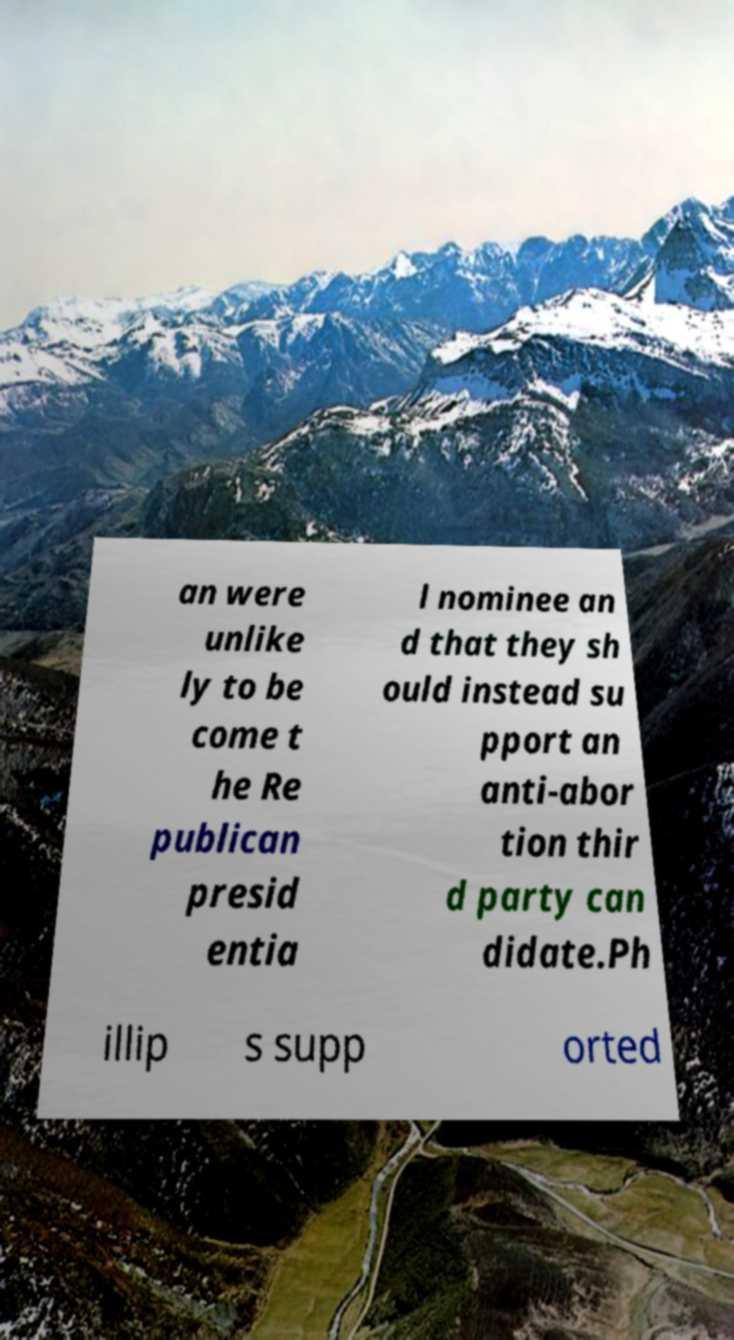Please identify and transcribe the text found in this image. an were unlike ly to be come t he Re publican presid entia l nominee an d that they sh ould instead su pport an anti-abor tion thir d party can didate.Ph illip s supp orted 